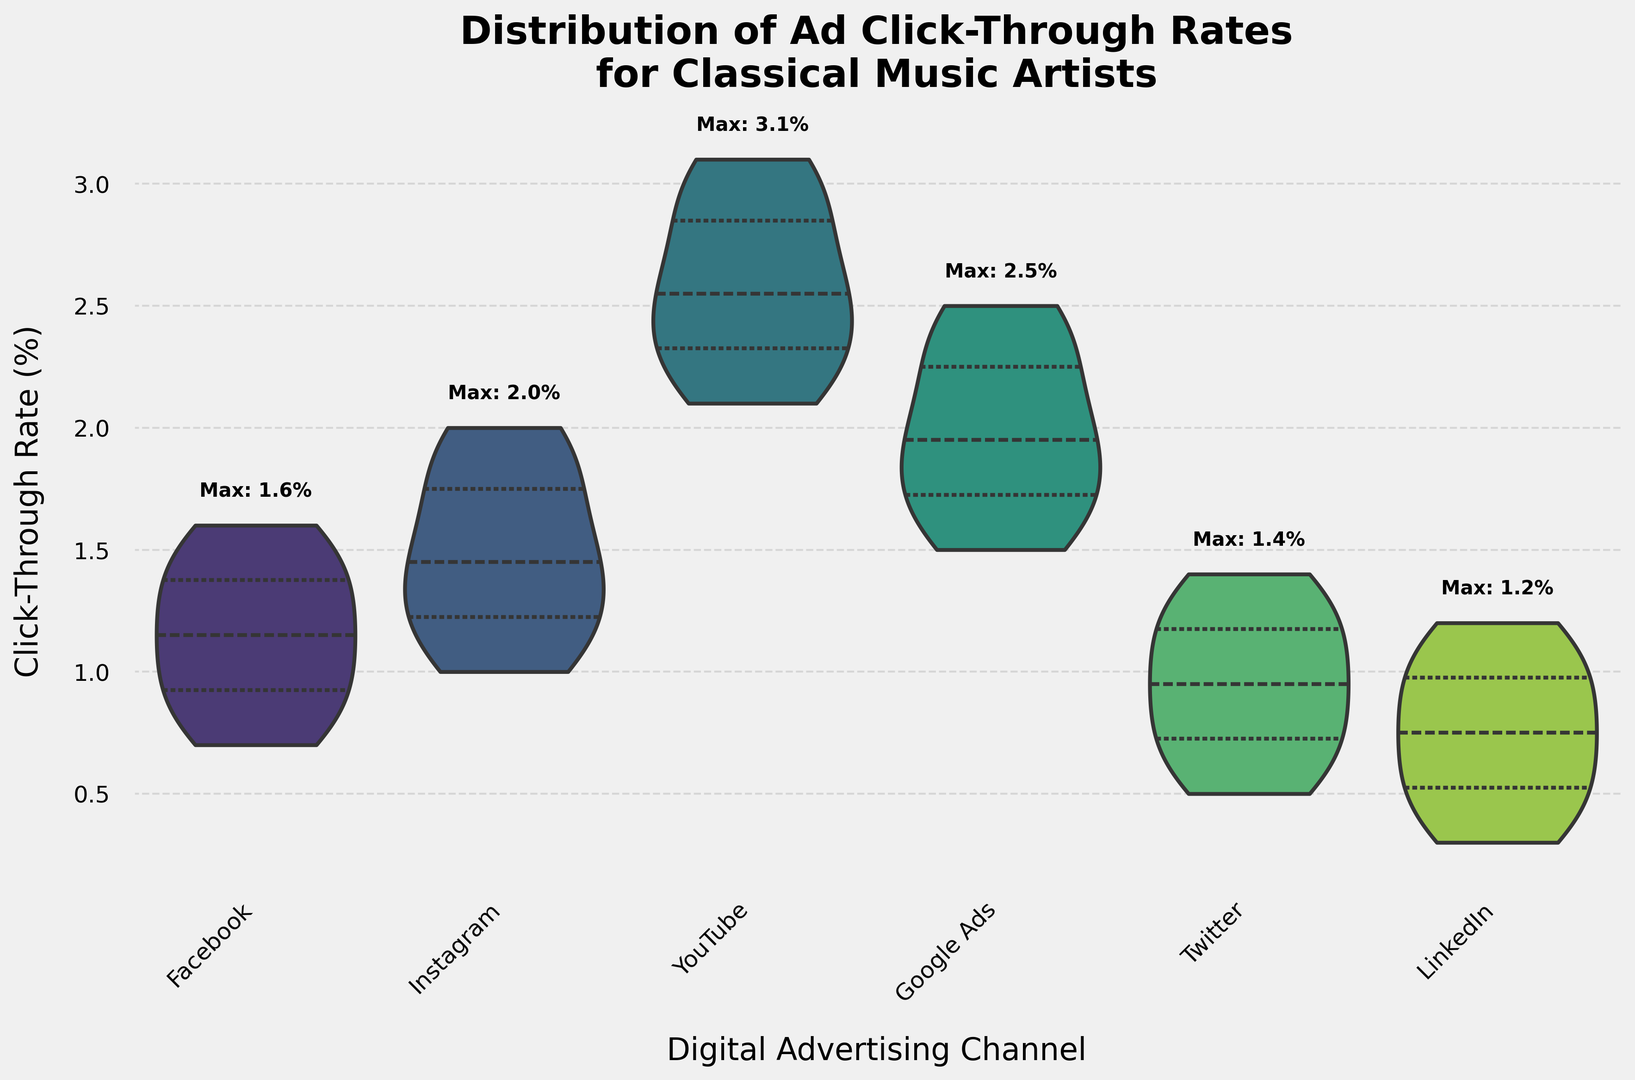What is the median click-through rate for Instagram? To find the median value, look at the center of the inner quartile section of the violin plot for Instagram. The median represents the midpoint where 50% of the data falls above and below.
Answer: 1.5% Which channel has the highest maximum click-through rate? Identify which channel has the highest point labeled "Max" in the figure. Look for the text annotation indicating the maximum value for each channel.
Answer: YouTube How does the width of the violin plots compare across the channels? Assess the width of each violin plot, which represents the distribution's density. Wider plots indicate a more varied click-through rate, while narrower plots show a more concentrated distribution.
Answer: YouTube and Google Ads are wider; LinkedIn is narrower What is the interquartile range (IQR) for the click-through rate on Facebook? Identify the span of the inner quartile region within the Facebook violin plot. The IQR is the difference between the 75th percentile and the 25th percentile within this plot. Estimate these values from the plot.
Answer: 0.7 (approx.) Which channel has the narrowest range of click-through rates? Look for the violin plot with the smallest vertical span from minimum to maximum values.
Answer: LinkedIn Compare the median click-through rates of Facebook and Twitter. Locate the median point (center of the inner quartile section) for both Facebook and Twitter and compare their values.
Answer: Facebook is higher What is the approximate span of click-through rates for LinkedIn? Identify the minimum and maximum points of the violin plot for LinkedIn and find the range by subtracting the minimum value from the maximum value.
Answer: 0.9 How does the distribution of click-through rates for Google Ads compare to Instagram? Compare the overall shape, width, and position of the inner quartile regions of the violin plots for Google Ads and Instagram to observe differences in distribution. Note the medians and range of data.
Answer: Google Ads has a higher range and a slightly higher median What is the relative spread of the click-through rates on Twitter compared to Facebook? Analyze the overall height and width of the violin plots for both Twitter and Facebook. Consider both the range of data (height) and the concentration of values (width).
Answer: Twitter has a narrower spread Which channel appears to have the least variability in its click-through rates? Determine which channel has the narrowest and most uniform violin plot, indicating consistent click-through rates close to the median.
Answer: LinkedIn 